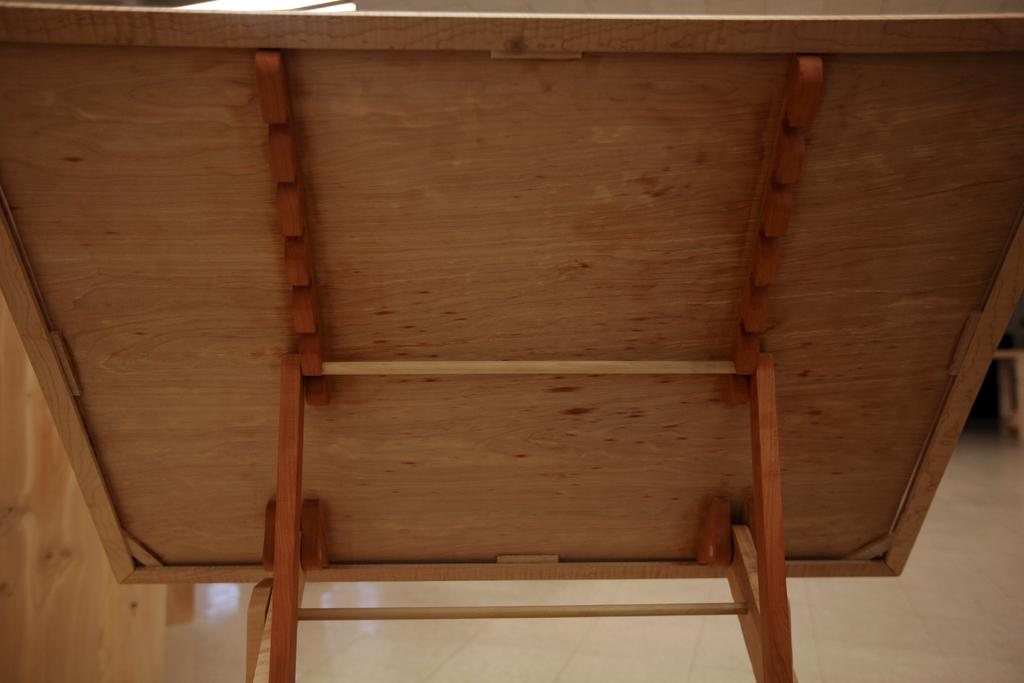What type of structure is present in the image? There is a wooden stand and a wooden board in the image. What might the wooden board be used for? The wooden board might be a painting board, as suggested by the facts. What is the material of the wall on the left side of the image? The wall on the left side of the image is made of wood. What is the color of the floor in the image? The floor is white in color. What type of nail is being used by the governor in the image? There is no governor or nail present in the image. What is the governor's opinion on the painting on the wooden board? There is no governor or painting present in the image, so it is not possible to determine the governor's opinion. 